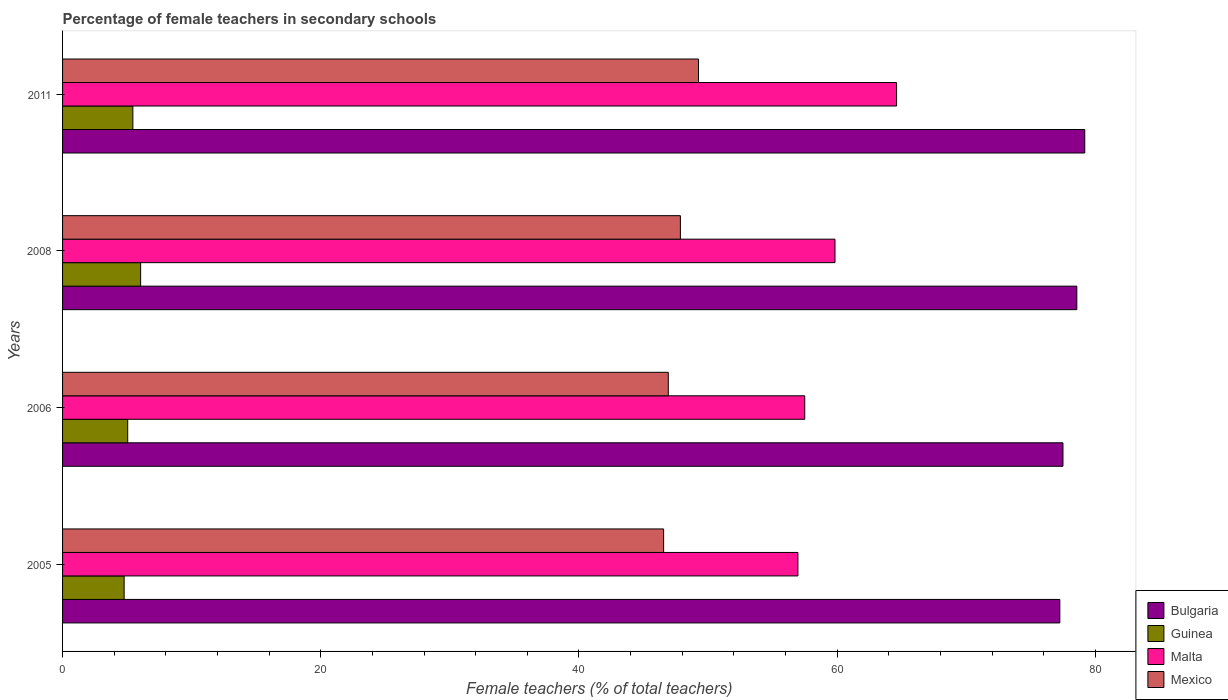How many groups of bars are there?
Give a very brief answer. 4. Are the number of bars per tick equal to the number of legend labels?
Offer a terse response. Yes. What is the percentage of female teachers in Mexico in 2011?
Give a very brief answer. 49.26. Across all years, what is the maximum percentage of female teachers in Malta?
Your answer should be compact. 64.6. Across all years, what is the minimum percentage of female teachers in Mexico?
Make the answer very short. 46.56. In which year was the percentage of female teachers in Bulgaria minimum?
Keep it short and to the point. 2005. What is the total percentage of female teachers in Malta in the graph?
Offer a terse response. 238.88. What is the difference between the percentage of female teachers in Bulgaria in 2008 and that in 2011?
Make the answer very short. -0.62. What is the difference between the percentage of female teachers in Malta in 2006 and the percentage of female teachers in Guinea in 2005?
Provide a short and direct response. 52.72. What is the average percentage of female teachers in Bulgaria per year?
Give a very brief answer. 78.12. In the year 2008, what is the difference between the percentage of female teachers in Bulgaria and percentage of female teachers in Malta?
Offer a very short reply. 18.73. What is the ratio of the percentage of female teachers in Malta in 2005 to that in 2006?
Offer a very short reply. 0.99. Is the percentage of female teachers in Bulgaria in 2006 less than that in 2011?
Your answer should be very brief. Yes. Is the difference between the percentage of female teachers in Bulgaria in 2008 and 2011 greater than the difference between the percentage of female teachers in Malta in 2008 and 2011?
Provide a succinct answer. Yes. What is the difference between the highest and the second highest percentage of female teachers in Bulgaria?
Provide a short and direct response. 0.62. What is the difference between the highest and the lowest percentage of female teachers in Bulgaria?
Ensure brevity in your answer.  1.93. Is the sum of the percentage of female teachers in Malta in 2006 and 2011 greater than the maximum percentage of female teachers in Bulgaria across all years?
Your answer should be compact. Yes. Is it the case that in every year, the sum of the percentage of female teachers in Malta and percentage of female teachers in Mexico is greater than the sum of percentage of female teachers in Guinea and percentage of female teachers in Bulgaria?
Keep it short and to the point. No. What does the 2nd bar from the top in 2008 represents?
Provide a short and direct response. Malta. What does the 4th bar from the bottom in 2011 represents?
Your answer should be very brief. Mexico. Is it the case that in every year, the sum of the percentage of female teachers in Guinea and percentage of female teachers in Bulgaria is greater than the percentage of female teachers in Mexico?
Make the answer very short. Yes. Are all the bars in the graph horizontal?
Offer a very short reply. Yes. What is the difference between two consecutive major ticks on the X-axis?
Your response must be concise. 20. Does the graph contain any zero values?
Make the answer very short. No. Where does the legend appear in the graph?
Your answer should be very brief. Bottom right. What is the title of the graph?
Your answer should be compact. Percentage of female teachers in secondary schools. Does "North America" appear as one of the legend labels in the graph?
Offer a very short reply. No. What is the label or title of the X-axis?
Your answer should be compact. Female teachers (% of total teachers). What is the label or title of the Y-axis?
Make the answer very short. Years. What is the Female teachers (% of total teachers) in Bulgaria in 2005?
Your response must be concise. 77.25. What is the Female teachers (% of total teachers) of Guinea in 2005?
Provide a succinct answer. 4.77. What is the Female teachers (% of total teachers) in Malta in 2005?
Provide a succinct answer. 56.96. What is the Female teachers (% of total teachers) in Mexico in 2005?
Keep it short and to the point. 46.56. What is the Female teachers (% of total teachers) in Bulgaria in 2006?
Ensure brevity in your answer.  77.49. What is the Female teachers (% of total teachers) of Guinea in 2006?
Your answer should be compact. 5.05. What is the Female teachers (% of total teachers) in Malta in 2006?
Provide a short and direct response. 57.49. What is the Female teachers (% of total teachers) in Mexico in 2006?
Ensure brevity in your answer.  46.92. What is the Female teachers (% of total teachers) in Bulgaria in 2008?
Offer a terse response. 78.56. What is the Female teachers (% of total teachers) in Guinea in 2008?
Make the answer very short. 6.05. What is the Female teachers (% of total teachers) in Malta in 2008?
Offer a very short reply. 59.83. What is the Female teachers (% of total teachers) in Mexico in 2008?
Offer a very short reply. 47.86. What is the Female teachers (% of total teachers) in Bulgaria in 2011?
Provide a short and direct response. 79.18. What is the Female teachers (% of total teachers) of Guinea in 2011?
Your answer should be compact. 5.44. What is the Female teachers (% of total teachers) in Malta in 2011?
Provide a short and direct response. 64.6. What is the Female teachers (% of total teachers) of Mexico in 2011?
Ensure brevity in your answer.  49.26. Across all years, what is the maximum Female teachers (% of total teachers) of Bulgaria?
Your answer should be compact. 79.18. Across all years, what is the maximum Female teachers (% of total teachers) of Guinea?
Your answer should be compact. 6.05. Across all years, what is the maximum Female teachers (% of total teachers) in Malta?
Provide a short and direct response. 64.6. Across all years, what is the maximum Female teachers (% of total teachers) in Mexico?
Provide a succinct answer. 49.26. Across all years, what is the minimum Female teachers (% of total teachers) of Bulgaria?
Provide a short and direct response. 77.25. Across all years, what is the minimum Female teachers (% of total teachers) in Guinea?
Make the answer very short. 4.77. Across all years, what is the minimum Female teachers (% of total teachers) of Malta?
Offer a terse response. 56.96. Across all years, what is the minimum Female teachers (% of total teachers) of Mexico?
Provide a short and direct response. 46.56. What is the total Female teachers (% of total teachers) in Bulgaria in the graph?
Offer a terse response. 312.48. What is the total Female teachers (% of total teachers) of Guinea in the graph?
Keep it short and to the point. 21.31. What is the total Female teachers (% of total teachers) in Malta in the graph?
Offer a very short reply. 238.88. What is the total Female teachers (% of total teachers) of Mexico in the graph?
Offer a very short reply. 190.59. What is the difference between the Female teachers (% of total teachers) of Bulgaria in 2005 and that in 2006?
Keep it short and to the point. -0.24. What is the difference between the Female teachers (% of total teachers) in Guinea in 2005 and that in 2006?
Ensure brevity in your answer.  -0.28. What is the difference between the Female teachers (% of total teachers) in Malta in 2005 and that in 2006?
Ensure brevity in your answer.  -0.53. What is the difference between the Female teachers (% of total teachers) of Mexico in 2005 and that in 2006?
Keep it short and to the point. -0.36. What is the difference between the Female teachers (% of total teachers) of Bulgaria in 2005 and that in 2008?
Your response must be concise. -1.32. What is the difference between the Female teachers (% of total teachers) in Guinea in 2005 and that in 2008?
Your answer should be compact. -1.28. What is the difference between the Female teachers (% of total teachers) in Malta in 2005 and that in 2008?
Provide a succinct answer. -2.87. What is the difference between the Female teachers (% of total teachers) of Mexico in 2005 and that in 2008?
Give a very brief answer. -1.3. What is the difference between the Female teachers (% of total teachers) of Bulgaria in 2005 and that in 2011?
Keep it short and to the point. -1.93. What is the difference between the Female teachers (% of total teachers) in Guinea in 2005 and that in 2011?
Provide a succinct answer. -0.67. What is the difference between the Female teachers (% of total teachers) in Malta in 2005 and that in 2011?
Ensure brevity in your answer.  -7.64. What is the difference between the Female teachers (% of total teachers) in Mexico in 2005 and that in 2011?
Make the answer very short. -2.7. What is the difference between the Female teachers (% of total teachers) in Bulgaria in 2006 and that in 2008?
Ensure brevity in your answer.  -1.07. What is the difference between the Female teachers (% of total teachers) in Guinea in 2006 and that in 2008?
Provide a succinct answer. -1. What is the difference between the Female teachers (% of total teachers) in Malta in 2006 and that in 2008?
Your answer should be very brief. -2.34. What is the difference between the Female teachers (% of total teachers) in Mexico in 2006 and that in 2008?
Provide a short and direct response. -0.94. What is the difference between the Female teachers (% of total teachers) of Bulgaria in 2006 and that in 2011?
Offer a terse response. -1.69. What is the difference between the Female teachers (% of total teachers) in Guinea in 2006 and that in 2011?
Provide a short and direct response. -0.4. What is the difference between the Female teachers (% of total teachers) in Malta in 2006 and that in 2011?
Keep it short and to the point. -7.11. What is the difference between the Female teachers (% of total teachers) of Mexico in 2006 and that in 2011?
Your answer should be compact. -2.34. What is the difference between the Female teachers (% of total teachers) in Bulgaria in 2008 and that in 2011?
Ensure brevity in your answer.  -0.62. What is the difference between the Female teachers (% of total teachers) in Guinea in 2008 and that in 2011?
Ensure brevity in your answer.  0.6. What is the difference between the Female teachers (% of total teachers) in Malta in 2008 and that in 2011?
Your response must be concise. -4.77. What is the difference between the Female teachers (% of total teachers) in Mexico in 2008 and that in 2011?
Your answer should be very brief. -1.4. What is the difference between the Female teachers (% of total teachers) in Bulgaria in 2005 and the Female teachers (% of total teachers) in Guinea in 2006?
Provide a succinct answer. 72.2. What is the difference between the Female teachers (% of total teachers) of Bulgaria in 2005 and the Female teachers (% of total teachers) of Malta in 2006?
Ensure brevity in your answer.  19.76. What is the difference between the Female teachers (% of total teachers) in Bulgaria in 2005 and the Female teachers (% of total teachers) in Mexico in 2006?
Provide a short and direct response. 30.33. What is the difference between the Female teachers (% of total teachers) in Guinea in 2005 and the Female teachers (% of total teachers) in Malta in 2006?
Provide a short and direct response. -52.72. What is the difference between the Female teachers (% of total teachers) of Guinea in 2005 and the Female teachers (% of total teachers) of Mexico in 2006?
Provide a succinct answer. -42.15. What is the difference between the Female teachers (% of total teachers) in Malta in 2005 and the Female teachers (% of total teachers) in Mexico in 2006?
Keep it short and to the point. 10.04. What is the difference between the Female teachers (% of total teachers) in Bulgaria in 2005 and the Female teachers (% of total teachers) in Guinea in 2008?
Offer a terse response. 71.2. What is the difference between the Female teachers (% of total teachers) of Bulgaria in 2005 and the Female teachers (% of total teachers) of Malta in 2008?
Keep it short and to the point. 17.42. What is the difference between the Female teachers (% of total teachers) in Bulgaria in 2005 and the Female teachers (% of total teachers) in Mexico in 2008?
Offer a terse response. 29.39. What is the difference between the Female teachers (% of total teachers) in Guinea in 2005 and the Female teachers (% of total teachers) in Malta in 2008?
Keep it short and to the point. -55.06. What is the difference between the Female teachers (% of total teachers) in Guinea in 2005 and the Female teachers (% of total teachers) in Mexico in 2008?
Give a very brief answer. -43.09. What is the difference between the Female teachers (% of total teachers) in Malta in 2005 and the Female teachers (% of total teachers) in Mexico in 2008?
Your answer should be compact. 9.1. What is the difference between the Female teachers (% of total teachers) of Bulgaria in 2005 and the Female teachers (% of total teachers) of Guinea in 2011?
Provide a succinct answer. 71.8. What is the difference between the Female teachers (% of total teachers) of Bulgaria in 2005 and the Female teachers (% of total teachers) of Malta in 2011?
Keep it short and to the point. 12.64. What is the difference between the Female teachers (% of total teachers) of Bulgaria in 2005 and the Female teachers (% of total teachers) of Mexico in 2011?
Your answer should be compact. 27.99. What is the difference between the Female teachers (% of total teachers) of Guinea in 2005 and the Female teachers (% of total teachers) of Malta in 2011?
Ensure brevity in your answer.  -59.83. What is the difference between the Female teachers (% of total teachers) in Guinea in 2005 and the Female teachers (% of total teachers) in Mexico in 2011?
Provide a short and direct response. -44.49. What is the difference between the Female teachers (% of total teachers) in Malta in 2005 and the Female teachers (% of total teachers) in Mexico in 2011?
Make the answer very short. 7.7. What is the difference between the Female teachers (% of total teachers) of Bulgaria in 2006 and the Female teachers (% of total teachers) of Guinea in 2008?
Offer a very short reply. 71.44. What is the difference between the Female teachers (% of total teachers) in Bulgaria in 2006 and the Female teachers (% of total teachers) in Malta in 2008?
Your answer should be very brief. 17.66. What is the difference between the Female teachers (% of total teachers) in Bulgaria in 2006 and the Female teachers (% of total teachers) in Mexico in 2008?
Keep it short and to the point. 29.63. What is the difference between the Female teachers (% of total teachers) of Guinea in 2006 and the Female teachers (% of total teachers) of Malta in 2008?
Your answer should be compact. -54.79. What is the difference between the Female teachers (% of total teachers) in Guinea in 2006 and the Female teachers (% of total teachers) in Mexico in 2008?
Ensure brevity in your answer.  -42.81. What is the difference between the Female teachers (% of total teachers) in Malta in 2006 and the Female teachers (% of total teachers) in Mexico in 2008?
Offer a very short reply. 9.63. What is the difference between the Female teachers (% of total teachers) of Bulgaria in 2006 and the Female teachers (% of total teachers) of Guinea in 2011?
Make the answer very short. 72.04. What is the difference between the Female teachers (% of total teachers) of Bulgaria in 2006 and the Female teachers (% of total teachers) of Malta in 2011?
Give a very brief answer. 12.89. What is the difference between the Female teachers (% of total teachers) of Bulgaria in 2006 and the Female teachers (% of total teachers) of Mexico in 2011?
Give a very brief answer. 28.23. What is the difference between the Female teachers (% of total teachers) in Guinea in 2006 and the Female teachers (% of total teachers) in Malta in 2011?
Give a very brief answer. -59.56. What is the difference between the Female teachers (% of total teachers) of Guinea in 2006 and the Female teachers (% of total teachers) of Mexico in 2011?
Keep it short and to the point. -44.21. What is the difference between the Female teachers (% of total teachers) of Malta in 2006 and the Female teachers (% of total teachers) of Mexico in 2011?
Your response must be concise. 8.23. What is the difference between the Female teachers (% of total teachers) of Bulgaria in 2008 and the Female teachers (% of total teachers) of Guinea in 2011?
Keep it short and to the point. 73.12. What is the difference between the Female teachers (% of total teachers) of Bulgaria in 2008 and the Female teachers (% of total teachers) of Malta in 2011?
Ensure brevity in your answer.  13.96. What is the difference between the Female teachers (% of total teachers) in Bulgaria in 2008 and the Female teachers (% of total teachers) in Mexico in 2011?
Offer a terse response. 29.31. What is the difference between the Female teachers (% of total teachers) of Guinea in 2008 and the Female teachers (% of total teachers) of Malta in 2011?
Ensure brevity in your answer.  -58.56. What is the difference between the Female teachers (% of total teachers) in Guinea in 2008 and the Female teachers (% of total teachers) in Mexico in 2011?
Provide a short and direct response. -43.21. What is the difference between the Female teachers (% of total teachers) in Malta in 2008 and the Female teachers (% of total teachers) in Mexico in 2011?
Keep it short and to the point. 10.57. What is the average Female teachers (% of total teachers) of Bulgaria per year?
Make the answer very short. 78.12. What is the average Female teachers (% of total teachers) in Guinea per year?
Your answer should be very brief. 5.33. What is the average Female teachers (% of total teachers) in Malta per year?
Provide a succinct answer. 59.72. What is the average Female teachers (% of total teachers) in Mexico per year?
Give a very brief answer. 47.65. In the year 2005, what is the difference between the Female teachers (% of total teachers) of Bulgaria and Female teachers (% of total teachers) of Guinea?
Your answer should be very brief. 72.48. In the year 2005, what is the difference between the Female teachers (% of total teachers) in Bulgaria and Female teachers (% of total teachers) in Malta?
Provide a short and direct response. 20.29. In the year 2005, what is the difference between the Female teachers (% of total teachers) of Bulgaria and Female teachers (% of total teachers) of Mexico?
Provide a succinct answer. 30.69. In the year 2005, what is the difference between the Female teachers (% of total teachers) in Guinea and Female teachers (% of total teachers) in Malta?
Your answer should be compact. -52.19. In the year 2005, what is the difference between the Female teachers (% of total teachers) in Guinea and Female teachers (% of total teachers) in Mexico?
Offer a very short reply. -41.79. In the year 2005, what is the difference between the Female teachers (% of total teachers) in Malta and Female teachers (% of total teachers) in Mexico?
Give a very brief answer. 10.4. In the year 2006, what is the difference between the Female teachers (% of total teachers) of Bulgaria and Female teachers (% of total teachers) of Guinea?
Ensure brevity in your answer.  72.44. In the year 2006, what is the difference between the Female teachers (% of total teachers) in Bulgaria and Female teachers (% of total teachers) in Malta?
Offer a very short reply. 20. In the year 2006, what is the difference between the Female teachers (% of total teachers) in Bulgaria and Female teachers (% of total teachers) in Mexico?
Your answer should be very brief. 30.57. In the year 2006, what is the difference between the Female teachers (% of total teachers) in Guinea and Female teachers (% of total teachers) in Malta?
Provide a succinct answer. -52.44. In the year 2006, what is the difference between the Female teachers (% of total teachers) of Guinea and Female teachers (% of total teachers) of Mexico?
Offer a terse response. -41.87. In the year 2006, what is the difference between the Female teachers (% of total teachers) of Malta and Female teachers (% of total teachers) of Mexico?
Make the answer very short. 10.57. In the year 2008, what is the difference between the Female teachers (% of total teachers) of Bulgaria and Female teachers (% of total teachers) of Guinea?
Your answer should be very brief. 72.52. In the year 2008, what is the difference between the Female teachers (% of total teachers) in Bulgaria and Female teachers (% of total teachers) in Malta?
Make the answer very short. 18.73. In the year 2008, what is the difference between the Female teachers (% of total teachers) of Bulgaria and Female teachers (% of total teachers) of Mexico?
Your response must be concise. 30.71. In the year 2008, what is the difference between the Female teachers (% of total teachers) in Guinea and Female teachers (% of total teachers) in Malta?
Make the answer very short. -53.78. In the year 2008, what is the difference between the Female teachers (% of total teachers) of Guinea and Female teachers (% of total teachers) of Mexico?
Keep it short and to the point. -41.81. In the year 2008, what is the difference between the Female teachers (% of total teachers) of Malta and Female teachers (% of total teachers) of Mexico?
Offer a very short reply. 11.98. In the year 2011, what is the difference between the Female teachers (% of total teachers) of Bulgaria and Female teachers (% of total teachers) of Guinea?
Offer a terse response. 73.73. In the year 2011, what is the difference between the Female teachers (% of total teachers) of Bulgaria and Female teachers (% of total teachers) of Malta?
Keep it short and to the point. 14.58. In the year 2011, what is the difference between the Female teachers (% of total teachers) of Bulgaria and Female teachers (% of total teachers) of Mexico?
Provide a succinct answer. 29.92. In the year 2011, what is the difference between the Female teachers (% of total teachers) of Guinea and Female teachers (% of total teachers) of Malta?
Offer a terse response. -59.16. In the year 2011, what is the difference between the Female teachers (% of total teachers) of Guinea and Female teachers (% of total teachers) of Mexico?
Ensure brevity in your answer.  -43.81. In the year 2011, what is the difference between the Female teachers (% of total teachers) in Malta and Female teachers (% of total teachers) in Mexico?
Your response must be concise. 15.35. What is the ratio of the Female teachers (% of total teachers) in Bulgaria in 2005 to that in 2006?
Your answer should be very brief. 1. What is the ratio of the Female teachers (% of total teachers) of Guinea in 2005 to that in 2006?
Provide a succinct answer. 0.95. What is the ratio of the Female teachers (% of total teachers) in Malta in 2005 to that in 2006?
Offer a terse response. 0.99. What is the ratio of the Female teachers (% of total teachers) of Bulgaria in 2005 to that in 2008?
Keep it short and to the point. 0.98. What is the ratio of the Female teachers (% of total teachers) in Guinea in 2005 to that in 2008?
Your answer should be compact. 0.79. What is the ratio of the Female teachers (% of total teachers) in Malta in 2005 to that in 2008?
Your response must be concise. 0.95. What is the ratio of the Female teachers (% of total teachers) of Mexico in 2005 to that in 2008?
Your answer should be very brief. 0.97. What is the ratio of the Female teachers (% of total teachers) of Bulgaria in 2005 to that in 2011?
Your answer should be very brief. 0.98. What is the ratio of the Female teachers (% of total teachers) in Guinea in 2005 to that in 2011?
Offer a terse response. 0.88. What is the ratio of the Female teachers (% of total teachers) in Malta in 2005 to that in 2011?
Give a very brief answer. 0.88. What is the ratio of the Female teachers (% of total teachers) of Mexico in 2005 to that in 2011?
Make the answer very short. 0.95. What is the ratio of the Female teachers (% of total teachers) of Bulgaria in 2006 to that in 2008?
Keep it short and to the point. 0.99. What is the ratio of the Female teachers (% of total teachers) in Guinea in 2006 to that in 2008?
Give a very brief answer. 0.83. What is the ratio of the Female teachers (% of total teachers) of Malta in 2006 to that in 2008?
Your answer should be compact. 0.96. What is the ratio of the Female teachers (% of total teachers) of Mexico in 2006 to that in 2008?
Give a very brief answer. 0.98. What is the ratio of the Female teachers (% of total teachers) in Bulgaria in 2006 to that in 2011?
Keep it short and to the point. 0.98. What is the ratio of the Female teachers (% of total teachers) of Guinea in 2006 to that in 2011?
Keep it short and to the point. 0.93. What is the ratio of the Female teachers (% of total teachers) of Malta in 2006 to that in 2011?
Give a very brief answer. 0.89. What is the ratio of the Female teachers (% of total teachers) in Mexico in 2006 to that in 2011?
Keep it short and to the point. 0.95. What is the ratio of the Female teachers (% of total teachers) in Bulgaria in 2008 to that in 2011?
Your response must be concise. 0.99. What is the ratio of the Female teachers (% of total teachers) of Guinea in 2008 to that in 2011?
Ensure brevity in your answer.  1.11. What is the ratio of the Female teachers (% of total teachers) of Malta in 2008 to that in 2011?
Make the answer very short. 0.93. What is the ratio of the Female teachers (% of total teachers) of Mexico in 2008 to that in 2011?
Ensure brevity in your answer.  0.97. What is the difference between the highest and the second highest Female teachers (% of total teachers) in Bulgaria?
Offer a terse response. 0.62. What is the difference between the highest and the second highest Female teachers (% of total teachers) of Guinea?
Your answer should be very brief. 0.6. What is the difference between the highest and the second highest Female teachers (% of total teachers) of Malta?
Keep it short and to the point. 4.77. What is the difference between the highest and the second highest Female teachers (% of total teachers) in Mexico?
Ensure brevity in your answer.  1.4. What is the difference between the highest and the lowest Female teachers (% of total teachers) in Bulgaria?
Keep it short and to the point. 1.93. What is the difference between the highest and the lowest Female teachers (% of total teachers) of Guinea?
Provide a short and direct response. 1.28. What is the difference between the highest and the lowest Female teachers (% of total teachers) in Malta?
Make the answer very short. 7.64. What is the difference between the highest and the lowest Female teachers (% of total teachers) in Mexico?
Provide a succinct answer. 2.7. 